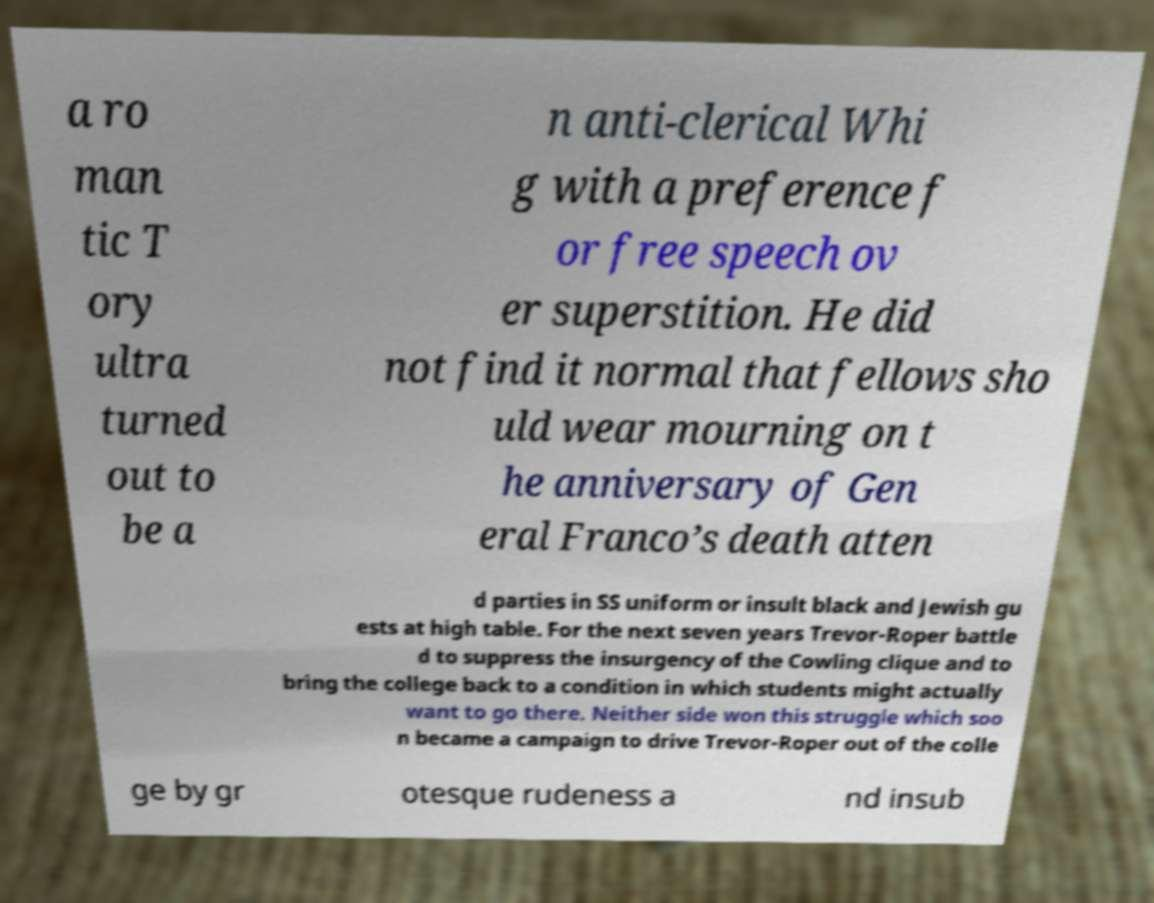Can you read and provide the text displayed in the image?This photo seems to have some interesting text. Can you extract and type it out for me? a ro man tic T ory ultra turned out to be a n anti-clerical Whi g with a preference f or free speech ov er superstition. He did not find it normal that fellows sho uld wear mourning on t he anniversary of Gen eral Franco’s death atten d parties in SS uniform or insult black and Jewish gu ests at high table. For the next seven years Trevor-Roper battle d to suppress the insurgency of the Cowling clique and to bring the college back to a condition in which students might actually want to go there. Neither side won this struggle which soo n became a campaign to drive Trevor-Roper out of the colle ge by gr otesque rudeness a nd insub 